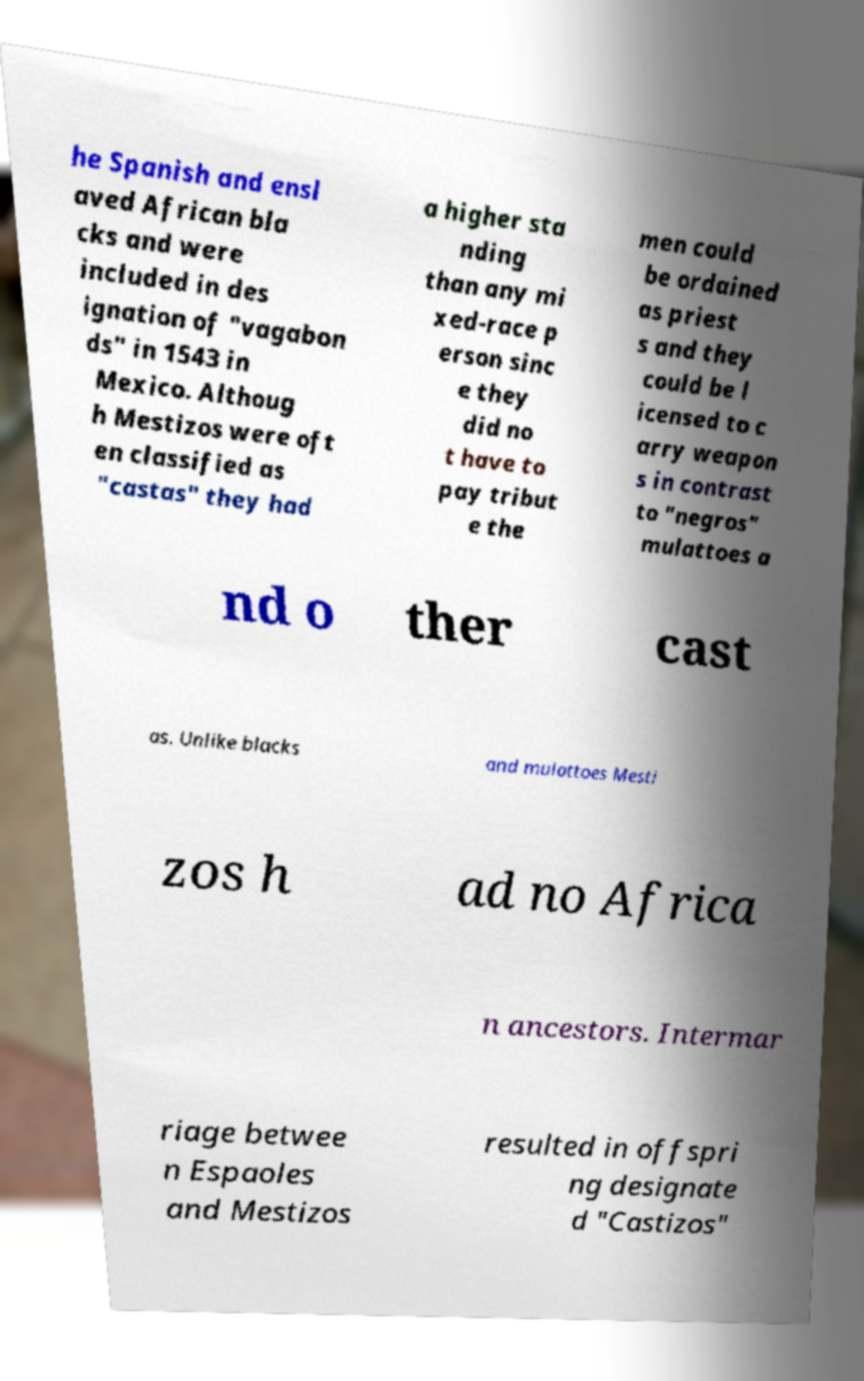Could you extract and type out the text from this image? he Spanish and ensl aved African bla cks and were included in des ignation of "vagabon ds" in 1543 in Mexico. Althoug h Mestizos were oft en classified as "castas" they had a higher sta nding than any mi xed-race p erson sinc e they did no t have to pay tribut e the men could be ordained as priest s and they could be l icensed to c arry weapon s in contrast to "negros" mulattoes a nd o ther cast as. Unlike blacks and mulattoes Mesti zos h ad no Africa n ancestors. Intermar riage betwee n Espaoles and Mestizos resulted in offspri ng designate d "Castizos" 